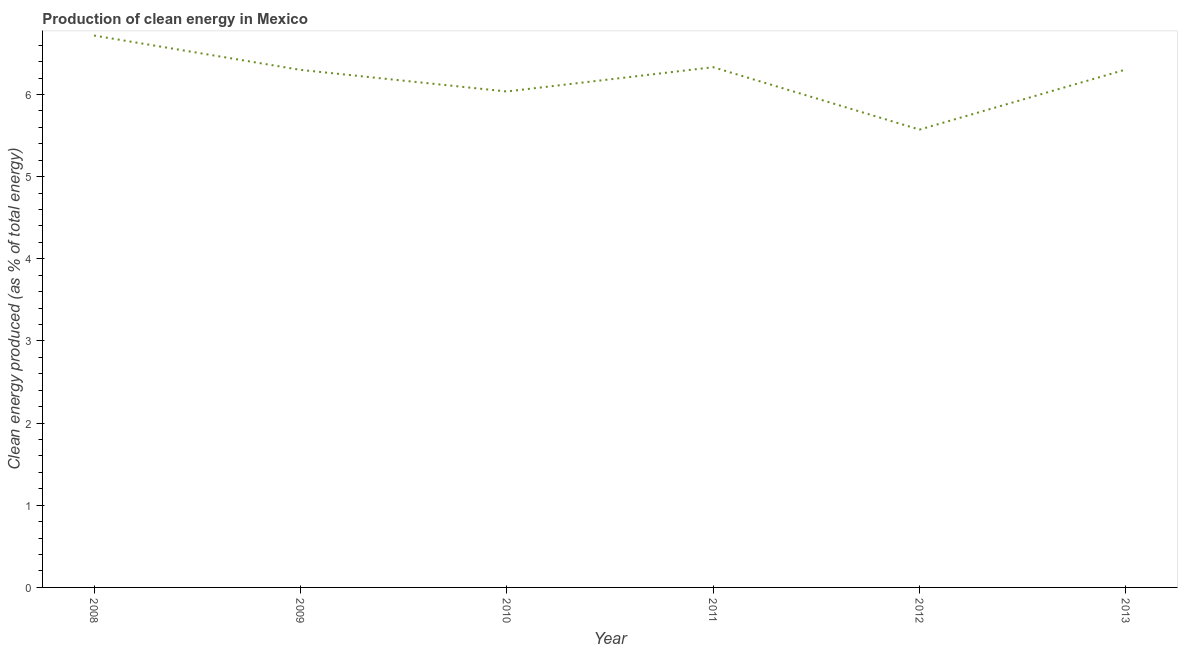What is the production of clean energy in 2009?
Offer a terse response. 6.3. Across all years, what is the maximum production of clean energy?
Your answer should be compact. 6.72. Across all years, what is the minimum production of clean energy?
Your answer should be very brief. 5.57. What is the sum of the production of clean energy?
Provide a short and direct response. 37.26. What is the difference between the production of clean energy in 2008 and 2011?
Offer a terse response. 0.39. What is the average production of clean energy per year?
Provide a succinct answer. 6.21. What is the median production of clean energy?
Offer a terse response. 6.3. In how many years, is the production of clean energy greater than 1.8 %?
Make the answer very short. 6. Do a majority of the years between 2012 and 2008 (inclusive) have production of clean energy greater than 2.6 %?
Your response must be concise. Yes. What is the ratio of the production of clean energy in 2008 to that in 2013?
Your response must be concise. 1.07. Is the production of clean energy in 2012 less than that in 2013?
Provide a short and direct response. Yes. Is the difference between the production of clean energy in 2010 and 2011 greater than the difference between any two years?
Your answer should be very brief. No. What is the difference between the highest and the second highest production of clean energy?
Your response must be concise. 0.39. What is the difference between the highest and the lowest production of clean energy?
Your answer should be very brief. 1.15. In how many years, is the production of clean energy greater than the average production of clean energy taken over all years?
Offer a terse response. 4. Does the production of clean energy monotonically increase over the years?
Your response must be concise. No. How many lines are there?
Offer a very short reply. 1. What is the difference between two consecutive major ticks on the Y-axis?
Make the answer very short. 1. Are the values on the major ticks of Y-axis written in scientific E-notation?
Keep it short and to the point. No. What is the title of the graph?
Your response must be concise. Production of clean energy in Mexico. What is the label or title of the X-axis?
Your response must be concise. Year. What is the label or title of the Y-axis?
Offer a very short reply. Clean energy produced (as % of total energy). What is the Clean energy produced (as % of total energy) in 2008?
Your answer should be compact. 6.72. What is the Clean energy produced (as % of total energy) of 2009?
Ensure brevity in your answer.  6.3. What is the Clean energy produced (as % of total energy) in 2010?
Keep it short and to the point. 6.04. What is the Clean energy produced (as % of total energy) of 2011?
Offer a very short reply. 6.33. What is the Clean energy produced (as % of total energy) of 2012?
Give a very brief answer. 5.57. What is the Clean energy produced (as % of total energy) in 2013?
Offer a very short reply. 6.3. What is the difference between the Clean energy produced (as % of total energy) in 2008 and 2009?
Your answer should be compact. 0.42. What is the difference between the Clean energy produced (as % of total energy) in 2008 and 2010?
Your answer should be very brief. 0.68. What is the difference between the Clean energy produced (as % of total energy) in 2008 and 2011?
Give a very brief answer. 0.39. What is the difference between the Clean energy produced (as % of total energy) in 2008 and 2012?
Provide a succinct answer. 1.15. What is the difference between the Clean energy produced (as % of total energy) in 2008 and 2013?
Offer a very short reply. 0.41. What is the difference between the Clean energy produced (as % of total energy) in 2009 and 2010?
Provide a short and direct response. 0.26. What is the difference between the Clean energy produced (as % of total energy) in 2009 and 2011?
Give a very brief answer. -0.03. What is the difference between the Clean energy produced (as % of total energy) in 2009 and 2012?
Your answer should be compact. 0.73. What is the difference between the Clean energy produced (as % of total energy) in 2009 and 2013?
Provide a short and direct response. -0. What is the difference between the Clean energy produced (as % of total energy) in 2010 and 2011?
Your response must be concise. -0.3. What is the difference between the Clean energy produced (as % of total energy) in 2010 and 2012?
Keep it short and to the point. 0.46. What is the difference between the Clean energy produced (as % of total energy) in 2010 and 2013?
Ensure brevity in your answer.  -0.27. What is the difference between the Clean energy produced (as % of total energy) in 2011 and 2012?
Give a very brief answer. 0.76. What is the difference between the Clean energy produced (as % of total energy) in 2011 and 2013?
Provide a short and direct response. 0.03. What is the difference between the Clean energy produced (as % of total energy) in 2012 and 2013?
Your response must be concise. -0.73. What is the ratio of the Clean energy produced (as % of total energy) in 2008 to that in 2009?
Your answer should be compact. 1.07. What is the ratio of the Clean energy produced (as % of total energy) in 2008 to that in 2010?
Keep it short and to the point. 1.11. What is the ratio of the Clean energy produced (as % of total energy) in 2008 to that in 2011?
Make the answer very short. 1.06. What is the ratio of the Clean energy produced (as % of total energy) in 2008 to that in 2012?
Your answer should be very brief. 1.21. What is the ratio of the Clean energy produced (as % of total energy) in 2008 to that in 2013?
Give a very brief answer. 1.07. What is the ratio of the Clean energy produced (as % of total energy) in 2009 to that in 2010?
Provide a succinct answer. 1.04. What is the ratio of the Clean energy produced (as % of total energy) in 2009 to that in 2012?
Your response must be concise. 1.13. What is the ratio of the Clean energy produced (as % of total energy) in 2010 to that in 2011?
Offer a terse response. 0.95. What is the ratio of the Clean energy produced (as % of total energy) in 2010 to that in 2012?
Your response must be concise. 1.08. What is the ratio of the Clean energy produced (as % of total energy) in 2010 to that in 2013?
Your answer should be very brief. 0.96. What is the ratio of the Clean energy produced (as % of total energy) in 2011 to that in 2012?
Your answer should be compact. 1.14. What is the ratio of the Clean energy produced (as % of total energy) in 2011 to that in 2013?
Make the answer very short. 1. What is the ratio of the Clean energy produced (as % of total energy) in 2012 to that in 2013?
Provide a succinct answer. 0.88. 